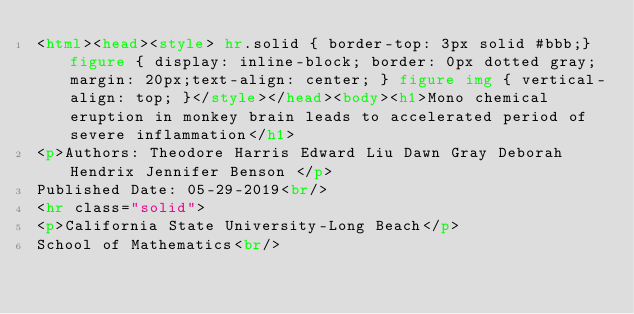<code> <loc_0><loc_0><loc_500><loc_500><_HTML_><html><head><style> hr.solid { border-top: 3px solid #bbb;} figure { display: inline-block; border: 0px dotted gray; margin: 20px;text-align: center; } figure img { vertical-align: top; }</style></head><body><h1>Mono chemical eruption in monkey brain leads to accelerated period of severe inflammation</h1>
<p>Authors: Theodore Harris Edward Liu Dawn Gray Deborah Hendrix Jennifer Benson </p>
Published Date: 05-29-2019<br/>
<hr class="solid">
<p>California State University-Long Beach</p>
School of Mathematics<br/></code> 